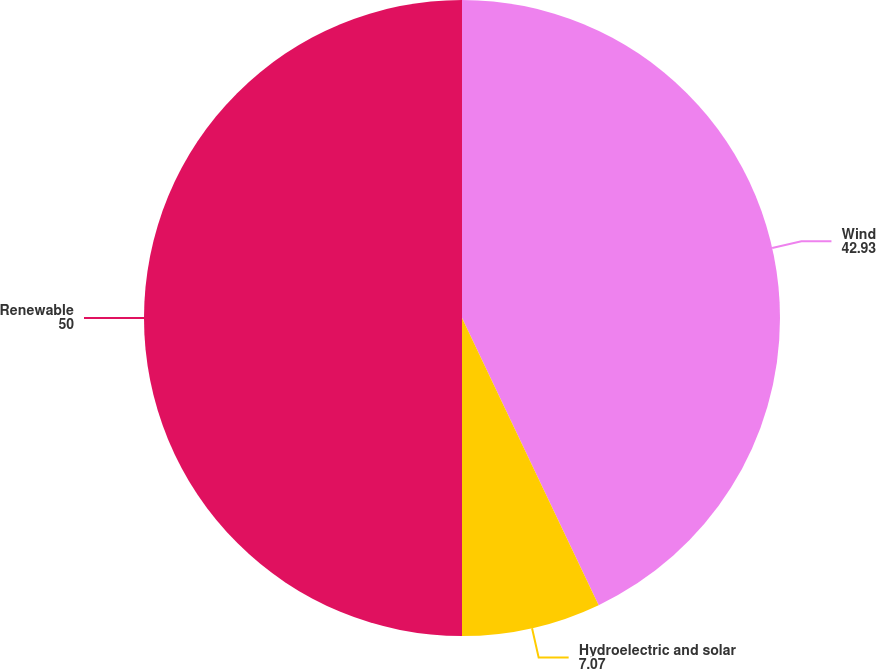<chart> <loc_0><loc_0><loc_500><loc_500><pie_chart><fcel>Wind<fcel>Hydroelectric and solar<fcel>Renewable<nl><fcel>42.93%<fcel>7.07%<fcel>50.0%<nl></chart> 